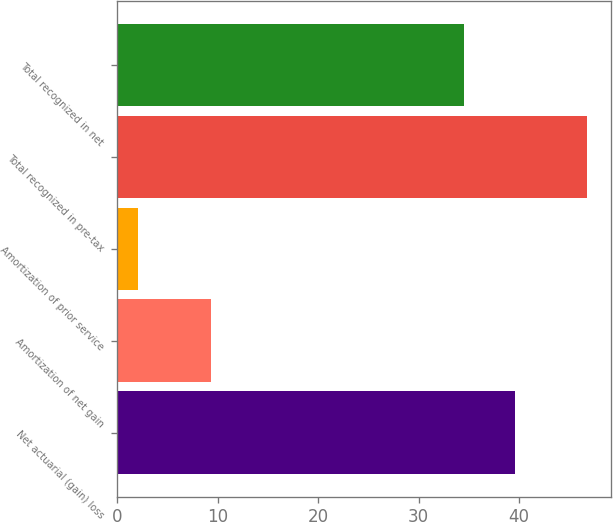<chart> <loc_0><loc_0><loc_500><loc_500><bar_chart><fcel>Net actuarial (gain) loss<fcel>Amortization of net gain<fcel>Amortization of prior service<fcel>Total recognized in pre-tax<fcel>Total recognized in net<nl><fcel>39.6<fcel>9.3<fcel>2.1<fcel>46.8<fcel>34.5<nl></chart> 